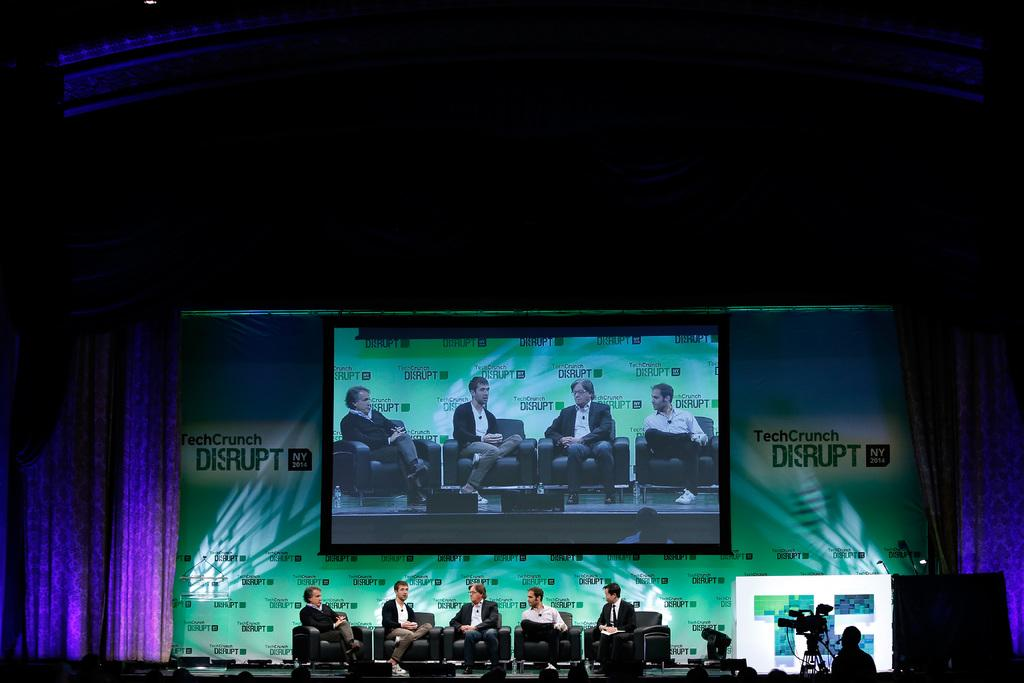<image>
Create a compact narrative representing the image presented. Five men sit on a large stage, beneath a large TV monitor, and in front of a large wall that says "TechCrunch Disrupt" all over it. 